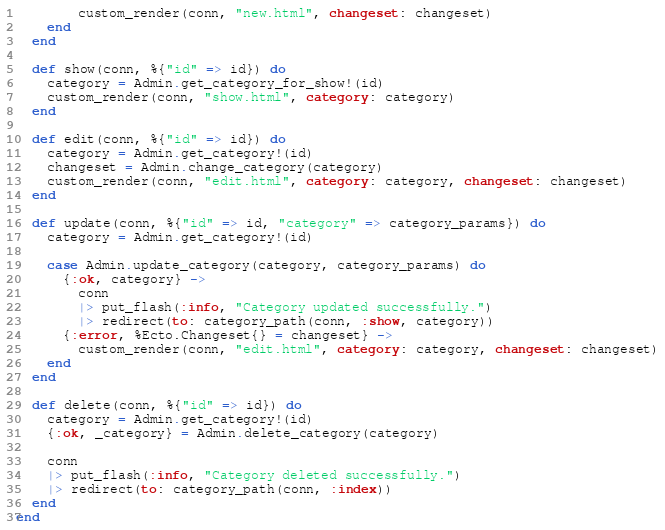<code> <loc_0><loc_0><loc_500><loc_500><_Elixir_>        custom_render(conn, "new.html", changeset: changeset)
    end
  end

  def show(conn, %{"id" => id}) do
    category = Admin.get_category_for_show!(id)
    custom_render(conn, "show.html", category: category)
  end

  def edit(conn, %{"id" => id}) do
    category = Admin.get_category!(id)
    changeset = Admin.change_category(category)
    custom_render(conn, "edit.html", category: category, changeset: changeset)
  end

  def update(conn, %{"id" => id, "category" => category_params}) do
    category = Admin.get_category!(id)

    case Admin.update_category(category, category_params) do
      {:ok, category} ->
        conn
        |> put_flash(:info, "Category updated successfully.")
        |> redirect(to: category_path(conn, :show, category))
      {:error, %Ecto.Changeset{} = changeset} ->
        custom_render(conn, "edit.html", category: category, changeset: changeset)
    end
  end

  def delete(conn, %{"id" => id}) do
    category = Admin.get_category!(id)
    {:ok, _category} = Admin.delete_category(category)

    conn
    |> put_flash(:info, "Category deleted successfully.")
    |> redirect(to: category_path(conn, :index))
  end
end
</code> 